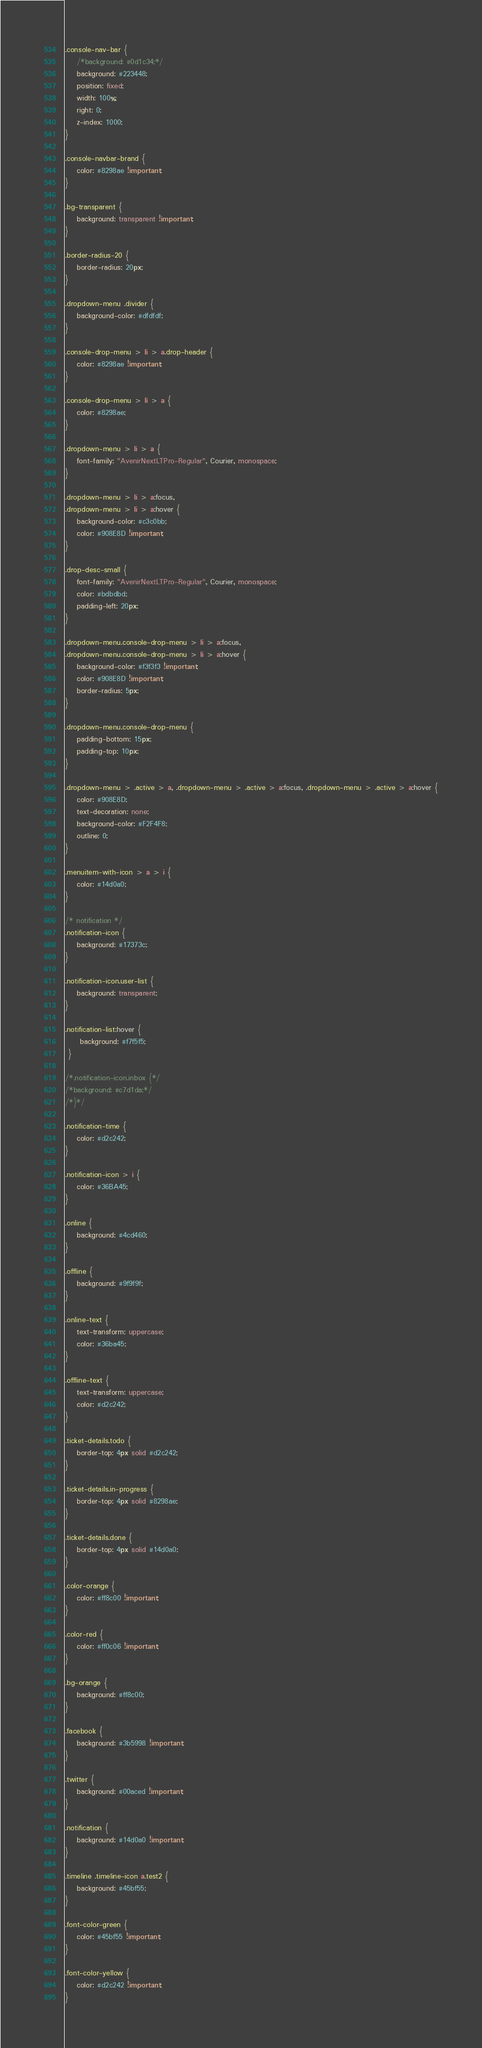<code> <loc_0><loc_0><loc_500><loc_500><_CSS_>
.console-nav-bar {
    /*background: #0d1c34;*/
    background: #223448;
    position: fixed;
    width: 100%;
    right: 0;
    z-index: 1000;
}

.console-navbar-brand {
    color: #8298ae !important;
}

.bg-transparent {
    background: transparent !important;
}

.border-radius-20 {
    border-radius: 20px;
}

.dropdown-menu .divider {
    background-color: #dfdfdf;
}

.console-drop-menu > li > a.drop-header {
    color: #8298ae !important;
}

.console-drop-menu > li > a {
    color: #8298ae;
}

.dropdown-menu > li > a {
    font-family: "AvenirNextLTPro-Regular", Courier, monospace;
}

.dropdown-menu > li > a:focus,
.dropdown-menu > li > a:hover {
    background-color: #c3c0bb;
    color: #908E8D !important;
}

.drop-desc-small {
    font-family: "AvenirNextLTPro-Regular", Courier, monospace;
    color: #bdbdbd;
    padding-left: 20px;
}

.dropdown-menu.console-drop-menu > li > a:focus,
.dropdown-menu.console-drop-menu > li > a:hover {
    background-color: #f3f3f3 !important;
    color: #908E8D !important;
    border-radius: 5px;
}

.dropdown-menu.console-drop-menu {
    padding-bottom: 15px;
    padding-top: 10px;
}

.dropdown-menu > .active > a, .dropdown-menu > .active > a:focus, .dropdown-menu > .active > a:hover {
    color: #908E8D;
    text-decoration: none;
    background-color: #F2F4F8;
    outline: 0;
}

.menuitem-with-icon > a > i {
    color: #14d0a0;
}

/* notification */
.notification-icon {
    background: #17373c;
}

.notification-icon.user-list {
    background: transparent;
}

.notification-list:hover {
     background: #f7f5f5;
 }

/*.notification-icon.inbox {*/
/*background: #c7d1da;*/
/*}*/

.notification-time {
    color: #d2c242;
}

.notification-icon > i {
    color: #36BA45;
}

.online {
    background: #4cd460;
}

.offline {
    background: #9f9f9f;
}

.online-text {
    text-transform: uppercase;
    color: #36ba45;
}

.offline-text {
    text-transform: uppercase;
    color: #d2c242;
}

.ticket-details.todo {
    border-top: 4px solid #d2c242;
}

.ticket-details.in-progress {
    border-top: 4px solid #8298ae;
}

.ticket-details.done {
    border-top: 4px solid #14d0a0;
}

.color-orange {
    color: #ff8c00 !important;
}

.color-red {
    color: #ff0c06 !important;
}

.bg-orange {
    background: #ff8c00;
}

.facebook {
    background: #3b5998 !important;
}

.twitter {
    background: #00aced !important;
}

.notification {
    background: #14d0a0 !important;
}

.timeline .timeline-icon a.test2 {
    background: #45bf55;
}

.font-color-green {
    color: #45bf55 !important;
}

.font-color-yellow {
    color: #d2c242 !important;
}
</code> 